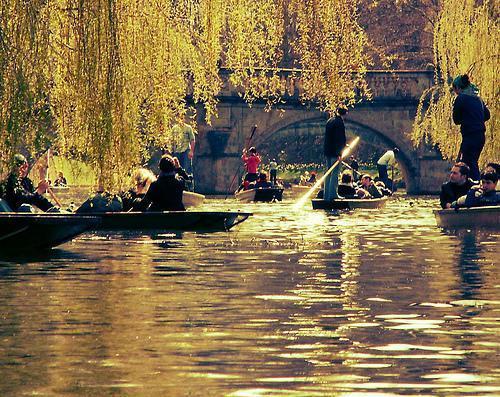How many boats are there?
Give a very brief answer. 6. How many people are there?
Give a very brief answer. 2. How many boats are in the picture?
Give a very brief answer. 2. How many surfboards in the water?
Give a very brief answer. 0. 